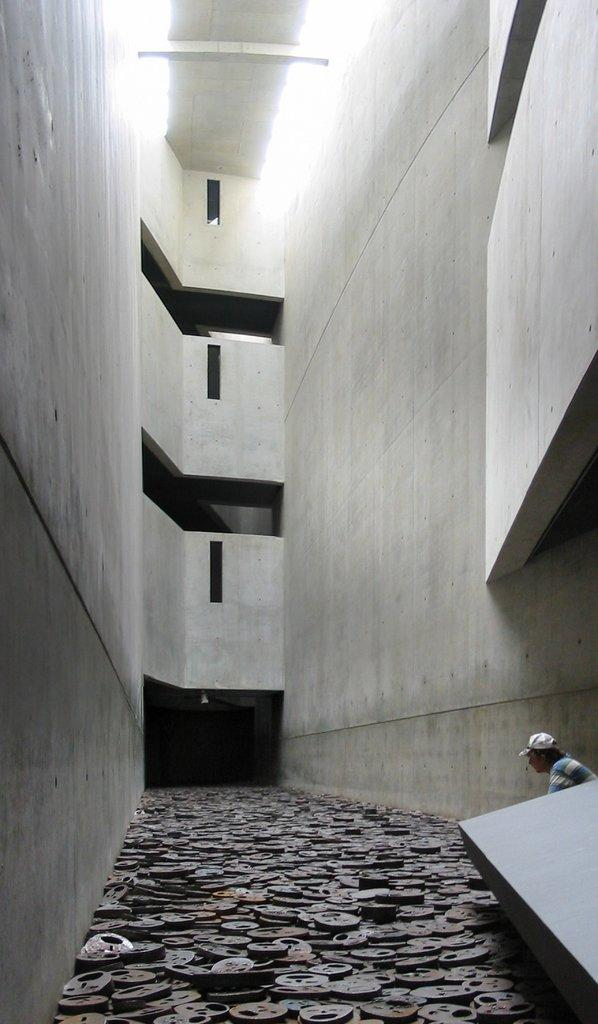What type of structure can be seen in the image? There are walls in the image, which suggests a room or building. Can you describe the person in the image? There is a person in the image, but no specific details about their appearance or actions are provided. What is on the floor in the image? There are objects on the floor in the image, but no specific details about these objects are provided. What type of bean is being used as a pest control method in the image? There is no bean or pest control method present in the image. What type of furniture can be seen in the image? The provided facts do not mention any furniture in the image. 